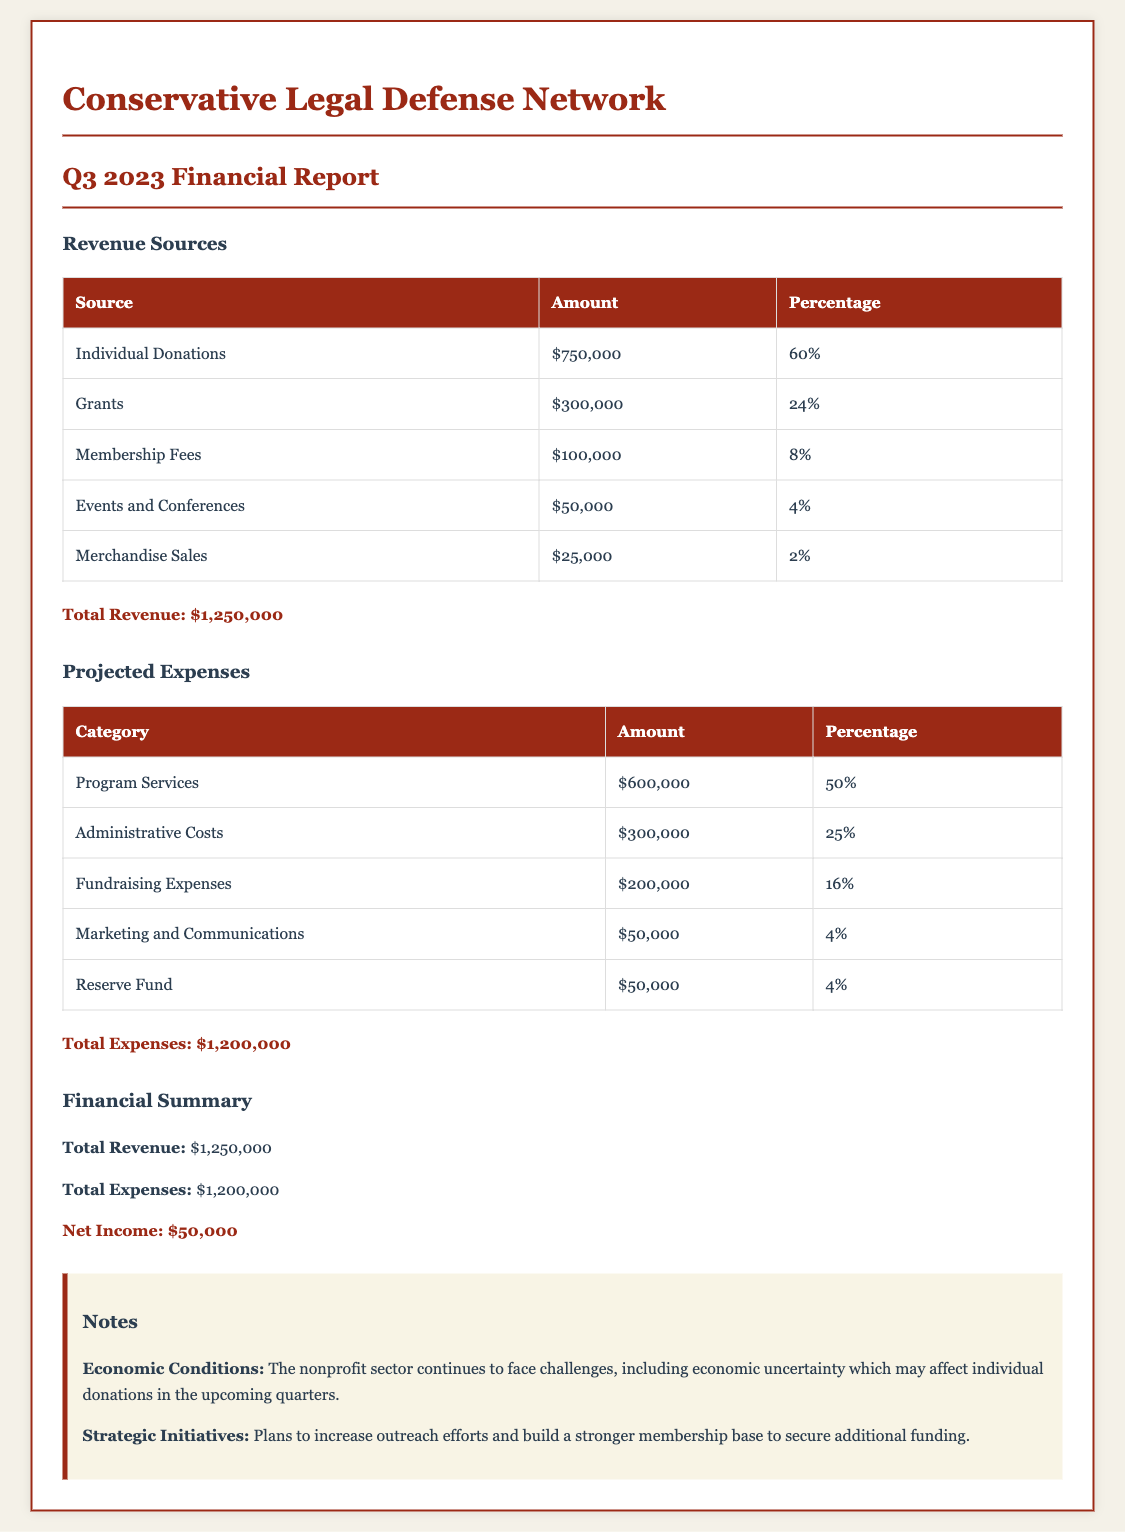What is the total revenue? The total revenue is provided in the financial summary section of the document, which states that it amounts to $1,250,000.
Answer: $1,250,000 What is the percentage of revenue from individual donations? The table for revenue sources shows that individual donations account for 60% of the total revenue.
Answer: 60% What is the amount allocated to program services? The projected expenses table indicates that the amount allocated to program services is $600,000.
Answer: $600,000 What is the projected expense for fundraising? According to the projected expenses table, fundraising expenses are projected to be $200,000.
Answer: $200,000 What is the net income as per the financial summary? The financial summary section calculates net income as total revenue minus total expenses, resulting in $50,000.
Answer: $50,000 What is the percentage of grant revenue? The revenue sources table states that grants contribute 24% to the total revenue.
Answer: 24% What is the total amount for administrative costs? The projected expenses table lists administrative costs at $300,000.
Answer: $300,000 What does the notes section mention about economic conditions? The notes provide an insight into economic conditions facing the nonprofit sector, indicating that there are challenges with economic uncertainty.
Answer: Economic uncertainty What percentage of total expenses is designated for marketing and communications? The projected expenses table shows that marketing and communications account for 4% of total expenses.
Answer: 4% What is the total projected expenses amount? The total projected expenses are provided in the financial summary, which states that it is $1,200,000.
Answer: $1,200,000 